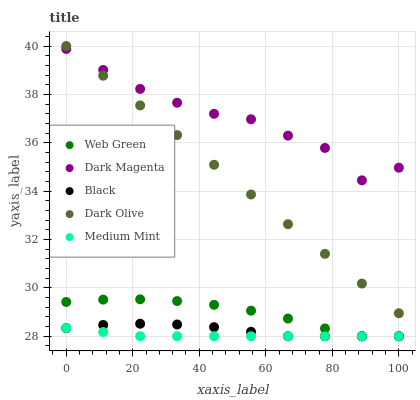Does Medium Mint have the minimum area under the curve?
Answer yes or no. Yes. Does Dark Magenta have the maximum area under the curve?
Answer yes or no. Yes. Does Dark Olive have the minimum area under the curve?
Answer yes or no. No. Does Dark Olive have the maximum area under the curve?
Answer yes or no. No. Is Dark Olive the smoothest?
Answer yes or no. Yes. Is Dark Magenta the roughest?
Answer yes or no. Yes. Is Black the smoothest?
Answer yes or no. No. Is Black the roughest?
Answer yes or no. No. Does Medium Mint have the lowest value?
Answer yes or no. Yes. Does Dark Olive have the lowest value?
Answer yes or no. No. Does Dark Olive have the highest value?
Answer yes or no. Yes. Does Black have the highest value?
Answer yes or no. No. Is Black less than Dark Magenta?
Answer yes or no. Yes. Is Dark Magenta greater than Web Green?
Answer yes or no. Yes. Does Dark Olive intersect Dark Magenta?
Answer yes or no. Yes. Is Dark Olive less than Dark Magenta?
Answer yes or no. No. Is Dark Olive greater than Dark Magenta?
Answer yes or no. No. Does Black intersect Dark Magenta?
Answer yes or no. No. 